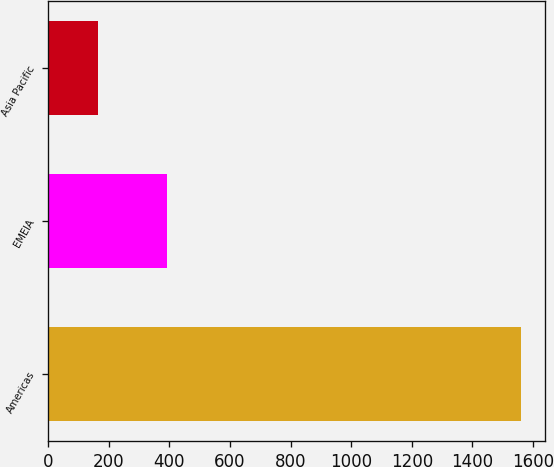Convert chart. <chart><loc_0><loc_0><loc_500><loc_500><bar_chart><fcel>Americas<fcel>EMEIA<fcel>Asia Pacific<nl><fcel>1560<fcel>393.4<fcel>164.9<nl></chart> 